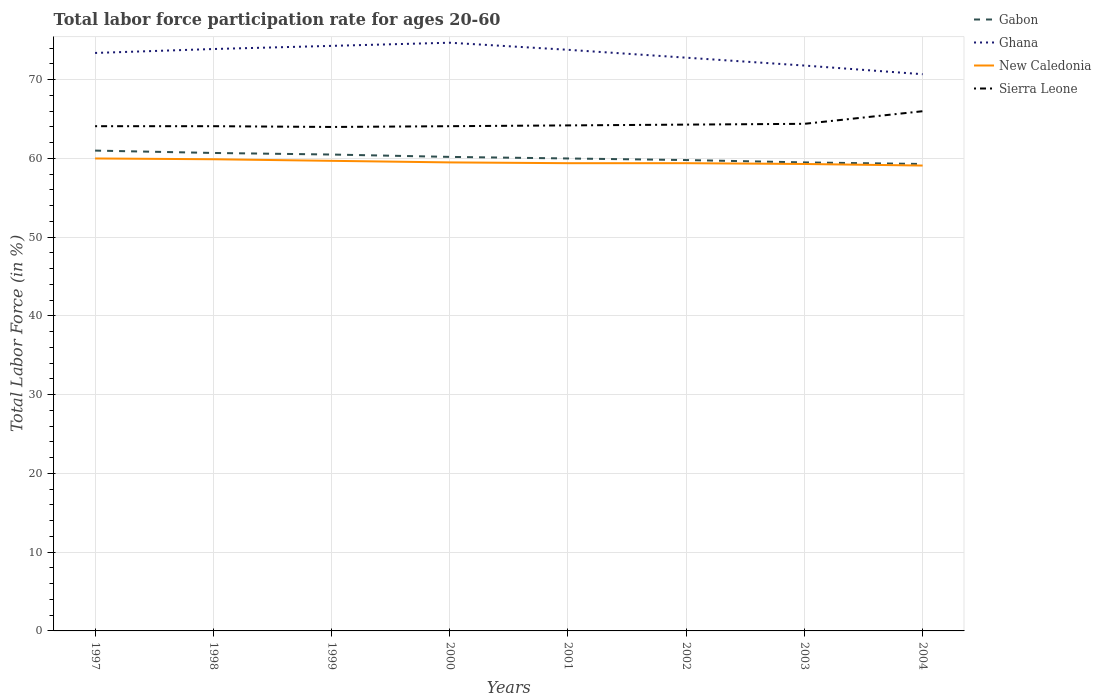Does the line corresponding to New Caledonia intersect with the line corresponding to Gabon?
Offer a terse response. No. Across all years, what is the maximum labor force participation rate in New Caledonia?
Make the answer very short. 59.1. What is the total labor force participation rate in Gabon in the graph?
Give a very brief answer. 0.2. What is the difference between the highest and the second highest labor force participation rate in Sierra Leone?
Make the answer very short. 2. What is the difference between the highest and the lowest labor force participation rate in Ghana?
Make the answer very short. 5. Are the values on the major ticks of Y-axis written in scientific E-notation?
Ensure brevity in your answer.  No. Does the graph contain grids?
Keep it short and to the point. Yes. Where does the legend appear in the graph?
Your response must be concise. Top right. How many legend labels are there?
Your response must be concise. 4. How are the legend labels stacked?
Give a very brief answer. Vertical. What is the title of the graph?
Give a very brief answer. Total labor force participation rate for ages 20-60. Does "Malta" appear as one of the legend labels in the graph?
Your answer should be compact. No. What is the label or title of the X-axis?
Give a very brief answer. Years. What is the Total Labor Force (in %) in Ghana in 1997?
Your answer should be very brief. 73.4. What is the Total Labor Force (in %) in New Caledonia in 1997?
Provide a succinct answer. 60. What is the Total Labor Force (in %) of Sierra Leone in 1997?
Your response must be concise. 64.1. What is the Total Labor Force (in %) of Gabon in 1998?
Provide a succinct answer. 60.7. What is the Total Labor Force (in %) of Ghana in 1998?
Make the answer very short. 73.9. What is the Total Labor Force (in %) of New Caledonia in 1998?
Offer a terse response. 59.9. What is the Total Labor Force (in %) of Sierra Leone in 1998?
Give a very brief answer. 64.1. What is the Total Labor Force (in %) in Gabon in 1999?
Your answer should be very brief. 60.5. What is the Total Labor Force (in %) of Ghana in 1999?
Ensure brevity in your answer.  74.3. What is the Total Labor Force (in %) of New Caledonia in 1999?
Offer a very short reply. 59.7. What is the Total Labor Force (in %) of Sierra Leone in 1999?
Provide a succinct answer. 64. What is the Total Labor Force (in %) of Gabon in 2000?
Keep it short and to the point. 60.2. What is the Total Labor Force (in %) in Ghana in 2000?
Provide a succinct answer. 74.7. What is the Total Labor Force (in %) of New Caledonia in 2000?
Make the answer very short. 59.5. What is the Total Labor Force (in %) of Sierra Leone in 2000?
Your answer should be compact. 64.1. What is the Total Labor Force (in %) in Ghana in 2001?
Ensure brevity in your answer.  73.8. What is the Total Labor Force (in %) in New Caledonia in 2001?
Offer a very short reply. 59.4. What is the Total Labor Force (in %) in Sierra Leone in 2001?
Keep it short and to the point. 64.2. What is the Total Labor Force (in %) in Gabon in 2002?
Keep it short and to the point. 59.8. What is the Total Labor Force (in %) in Ghana in 2002?
Your answer should be very brief. 72.8. What is the Total Labor Force (in %) in New Caledonia in 2002?
Your response must be concise. 59.4. What is the Total Labor Force (in %) in Sierra Leone in 2002?
Provide a succinct answer. 64.3. What is the Total Labor Force (in %) of Gabon in 2003?
Your response must be concise. 59.5. What is the Total Labor Force (in %) in Ghana in 2003?
Your answer should be very brief. 71.8. What is the Total Labor Force (in %) of New Caledonia in 2003?
Make the answer very short. 59.3. What is the Total Labor Force (in %) in Sierra Leone in 2003?
Ensure brevity in your answer.  64.4. What is the Total Labor Force (in %) of Gabon in 2004?
Keep it short and to the point. 59.3. What is the Total Labor Force (in %) of Ghana in 2004?
Offer a terse response. 70.7. What is the Total Labor Force (in %) of New Caledonia in 2004?
Ensure brevity in your answer.  59.1. What is the Total Labor Force (in %) in Sierra Leone in 2004?
Ensure brevity in your answer.  66. Across all years, what is the maximum Total Labor Force (in %) of Ghana?
Give a very brief answer. 74.7. Across all years, what is the maximum Total Labor Force (in %) in Sierra Leone?
Your response must be concise. 66. Across all years, what is the minimum Total Labor Force (in %) in Gabon?
Your answer should be very brief. 59.3. Across all years, what is the minimum Total Labor Force (in %) of Ghana?
Ensure brevity in your answer.  70.7. Across all years, what is the minimum Total Labor Force (in %) of New Caledonia?
Offer a terse response. 59.1. What is the total Total Labor Force (in %) of Gabon in the graph?
Keep it short and to the point. 481. What is the total Total Labor Force (in %) of Ghana in the graph?
Offer a terse response. 585.4. What is the total Total Labor Force (in %) of New Caledonia in the graph?
Your answer should be very brief. 476.3. What is the total Total Labor Force (in %) of Sierra Leone in the graph?
Ensure brevity in your answer.  515.2. What is the difference between the Total Labor Force (in %) of Ghana in 1997 and that in 1998?
Make the answer very short. -0.5. What is the difference between the Total Labor Force (in %) of Sierra Leone in 1997 and that in 1998?
Your answer should be compact. 0. What is the difference between the Total Labor Force (in %) of New Caledonia in 1997 and that in 1999?
Offer a terse response. 0.3. What is the difference between the Total Labor Force (in %) of Sierra Leone in 1997 and that in 2000?
Your answer should be compact. 0. What is the difference between the Total Labor Force (in %) of New Caledonia in 1997 and that in 2001?
Offer a very short reply. 0.6. What is the difference between the Total Labor Force (in %) in Sierra Leone in 1997 and that in 2002?
Offer a very short reply. -0.2. What is the difference between the Total Labor Force (in %) of Gabon in 1997 and that in 2003?
Your answer should be compact. 1.5. What is the difference between the Total Labor Force (in %) of Ghana in 1997 and that in 2003?
Offer a terse response. 1.6. What is the difference between the Total Labor Force (in %) of Sierra Leone in 1997 and that in 2003?
Provide a short and direct response. -0.3. What is the difference between the Total Labor Force (in %) in Ghana in 1997 and that in 2004?
Make the answer very short. 2.7. What is the difference between the Total Labor Force (in %) in New Caledonia in 1997 and that in 2004?
Ensure brevity in your answer.  0.9. What is the difference between the Total Labor Force (in %) of Sierra Leone in 1997 and that in 2004?
Provide a short and direct response. -1.9. What is the difference between the Total Labor Force (in %) in Sierra Leone in 1998 and that in 1999?
Your answer should be compact. 0.1. What is the difference between the Total Labor Force (in %) in Gabon in 1998 and that in 2000?
Provide a succinct answer. 0.5. What is the difference between the Total Labor Force (in %) of Ghana in 1998 and that in 2000?
Make the answer very short. -0.8. What is the difference between the Total Labor Force (in %) in New Caledonia in 1998 and that in 2000?
Keep it short and to the point. 0.4. What is the difference between the Total Labor Force (in %) in Gabon in 1998 and that in 2002?
Provide a short and direct response. 0.9. What is the difference between the Total Labor Force (in %) in Ghana in 1998 and that in 2002?
Your answer should be compact. 1.1. What is the difference between the Total Labor Force (in %) in New Caledonia in 1998 and that in 2002?
Your answer should be compact. 0.5. What is the difference between the Total Labor Force (in %) in Sierra Leone in 1998 and that in 2002?
Keep it short and to the point. -0.2. What is the difference between the Total Labor Force (in %) of Gabon in 1998 and that in 2003?
Provide a short and direct response. 1.2. What is the difference between the Total Labor Force (in %) in New Caledonia in 1998 and that in 2003?
Offer a terse response. 0.6. What is the difference between the Total Labor Force (in %) of Sierra Leone in 1998 and that in 2003?
Your answer should be compact. -0.3. What is the difference between the Total Labor Force (in %) of Ghana in 1998 and that in 2004?
Your answer should be very brief. 3.2. What is the difference between the Total Labor Force (in %) of Sierra Leone in 1998 and that in 2004?
Provide a succinct answer. -1.9. What is the difference between the Total Labor Force (in %) of New Caledonia in 1999 and that in 2000?
Provide a short and direct response. 0.2. What is the difference between the Total Labor Force (in %) in Gabon in 1999 and that in 2001?
Provide a short and direct response. 0.5. What is the difference between the Total Labor Force (in %) in Ghana in 1999 and that in 2001?
Ensure brevity in your answer.  0.5. What is the difference between the Total Labor Force (in %) in New Caledonia in 1999 and that in 2001?
Offer a very short reply. 0.3. What is the difference between the Total Labor Force (in %) of Sierra Leone in 1999 and that in 2001?
Keep it short and to the point. -0.2. What is the difference between the Total Labor Force (in %) of Gabon in 1999 and that in 2002?
Give a very brief answer. 0.7. What is the difference between the Total Labor Force (in %) in Ghana in 1999 and that in 2002?
Keep it short and to the point. 1.5. What is the difference between the Total Labor Force (in %) of Ghana in 1999 and that in 2003?
Offer a very short reply. 2.5. What is the difference between the Total Labor Force (in %) of New Caledonia in 1999 and that in 2003?
Your answer should be very brief. 0.4. What is the difference between the Total Labor Force (in %) in Sierra Leone in 1999 and that in 2004?
Provide a short and direct response. -2. What is the difference between the Total Labor Force (in %) in New Caledonia in 2000 and that in 2001?
Your answer should be compact. 0.1. What is the difference between the Total Labor Force (in %) in Sierra Leone in 2000 and that in 2001?
Give a very brief answer. -0.1. What is the difference between the Total Labor Force (in %) in New Caledonia in 2000 and that in 2002?
Provide a short and direct response. 0.1. What is the difference between the Total Labor Force (in %) of Sierra Leone in 2000 and that in 2002?
Offer a terse response. -0.2. What is the difference between the Total Labor Force (in %) in New Caledonia in 2000 and that in 2004?
Make the answer very short. 0.4. What is the difference between the Total Labor Force (in %) of Sierra Leone in 2000 and that in 2004?
Offer a terse response. -1.9. What is the difference between the Total Labor Force (in %) of Gabon in 2001 and that in 2002?
Offer a terse response. 0.2. What is the difference between the Total Labor Force (in %) of Ghana in 2001 and that in 2003?
Give a very brief answer. 2. What is the difference between the Total Labor Force (in %) of New Caledonia in 2001 and that in 2003?
Provide a short and direct response. 0.1. What is the difference between the Total Labor Force (in %) in Ghana in 2001 and that in 2004?
Give a very brief answer. 3.1. What is the difference between the Total Labor Force (in %) of New Caledonia in 2001 and that in 2004?
Keep it short and to the point. 0.3. What is the difference between the Total Labor Force (in %) of Ghana in 2002 and that in 2003?
Your answer should be compact. 1. What is the difference between the Total Labor Force (in %) of New Caledonia in 2002 and that in 2003?
Ensure brevity in your answer.  0.1. What is the difference between the Total Labor Force (in %) in Gabon in 2002 and that in 2004?
Your answer should be very brief. 0.5. What is the difference between the Total Labor Force (in %) in Ghana in 2002 and that in 2004?
Give a very brief answer. 2.1. What is the difference between the Total Labor Force (in %) in Gabon in 2003 and that in 2004?
Keep it short and to the point. 0.2. What is the difference between the Total Labor Force (in %) of Sierra Leone in 2003 and that in 2004?
Your response must be concise. -1.6. What is the difference between the Total Labor Force (in %) of Gabon in 1997 and the Total Labor Force (in %) of New Caledonia in 1998?
Give a very brief answer. 1.1. What is the difference between the Total Labor Force (in %) in Gabon in 1997 and the Total Labor Force (in %) in Sierra Leone in 1998?
Your response must be concise. -3.1. What is the difference between the Total Labor Force (in %) of Ghana in 1997 and the Total Labor Force (in %) of New Caledonia in 1999?
Give a very brief answer. 13.7. What is the difference between the Total Labor Force (in %) of New Caledonia in 1997 and the Total Labor Force (in %) of Sierra Leone in 1999?
Give a very brief answer. -4. What is the difference between the Total Labor Force (in %) in Gabon in 1997 and the Total Labor Force (in %) in Ghana in 2000?
Your response must be concise. -13.7. What is the difference between the Total Labor Force (in %) of Gabon in 1997 and the Total Labor Force (in %) of New Caledonia in 2000?
Keep it short and to the point. 1.5. What is the difference between the Total Labor Force (in %) of Gabon in 1997 and the Total Labor Force (in %) of Ghana in 2001?
Make the answer very short. -12.8. What is the difference between the Total Labor Force (in %) of Gabon in 1997 and the Total Labor Force (in %) of Ghana in 2002?
Ensure brevity in your answer.  -11.8. What is the difference between the Total Labor Force (in %) in Gabon in 1997 and the Total Labor Force (in %) in Sierra Leone in 2002?
Give a very brief answer. -3.3. What is the difference between the Total Labor Force (in %) of Ghana in 1997 and the Total Labor Force (in %) of New Caledonia in 2002?
Offer a very short reply. 14. What is the difference between the Total Labor Force (in %) of New Caledonia in 1997 and the Total Labor Force (in %) of Sierra Leone in 2002?
Offer a terse response. -4.3. What is the difference between the Total Labor Force (in %) in Gabon in 1997 and the Total Labor Force (in %) in New Caledonia in 2003?
Your answer should be compact. 1.7. What is the difference between the Total Labor Force (in %) in Gabon in 1997 and the Total Labor Force (in %) in Sierra Leone in 2003?
Offer a very short reply. -3.4. What is the difference between the Total Labor Force (in %) in Ghana in 1997 and the Total Labor Force (in %) in New Caledonia in 2003?
Offer a terse response. 14.1. What is the difference between the Total Labor Force (in %) of Ghana in 1997 and the Total Labor Force (in %) of Sierra Leone in 2003?
Give a very brief answer. 9. What is the difference between the Total Labor Force (in %) of Gabon in 1997 and the Total Labor Force (in %) of New Caledonia in 2004?
Offer a very short reply. 1.9. What is the difference between the Total Labor Force (in %) in Gabon in 1997 and the Total Labor Force (in %) in Sierra Leone in 2004?
Ensure brevity in your answer.  -5. What is the difference between the Total Labor Force (in %) in Ghana in 1997 and the Total Labor Force (in %) in New Caledonia in 2004?
Your answer should be compact. 14.3. What is the difference between the Total Labor Force (in %) in New Caledonia in 1997 and the Total Labor Force (in %) in Sierra Leone in 2004?
Ensure brevity in your answer.  -6. What is the difference between the Total Labor Force (in %) of Gabon in 1998 and the Total Labor Force (in %) of Ghana in 1999?
Keep it short and to the point. -13.6. What is the difference between the Total Labor Force (in %) of Gabon in 1998 and the Total Labor Force (in %) of Ghana in 2000?
Your answer should be very brief. -14. What is the difference between the Total Labor Force (in %) in Ghana in 1998 and the Total Labor Force (in %) in Sierra Leone in 2000?
Make the answer very short. 9.8. What is the difference between the Total Labor Force (in %) of New Caledonia in 1998 and the Total Labor Force (in %) of Sierra Leone in 2000?
Offer a very short reply. -4.2. What is the difference between the Total Labor Force (in %) of Gabon in 1998 and the Total Labor Force (in %) of Sierra Leone in 2001?
Make the answer very short. -3.5. What is the difference between the Total Labor Force (in %) in Ghana in 1998 and the Total Labor Force (in %) in Sierra Leone in 2001?
Ensure brevity in your answer.  9.7. What is the difference between the Total Labor Force (in %) of Gabon in 1998 and the Total Labor Force (in %) of Ghana in 2002?
Give a very brief answer. -12.1. What is the difference between the Total Labor Force (in %) in Gabon in 1998 and the Total Labor Force (in %) in Sierra Leone in 2002?
Provide a succinct answer. -3.6. What is the difference between the Total Labor Force (in %) in Ghana in 1998 and the Total Labor Force (in %) in New Caledonia in 2002?
Provide a short and direct response. 14.5. What is the difference between the Total Labor Force (in %) of Ghana in 1998 and the Total Labor Force (in %) of Sierra Leone in 2002?
Provide a succinct answer. 9.6. What is the difference between the Total Labor Force (in %) of New Caledonia in 1998 and the Total Labor Force (in %) of Sierra Leone in 2002?
Give a very brief answer. -4.4. What is the difference between the Total Labor Force (in %) in Gabon in 1998 and the Total Labor Force (in %) in New Caledonia in 2003?
Make the answer very short. 1.4. What is the difference between the Total Labor Force (in %) of Gabon in 1998 and the Total Labor Force (in %) of Sierra Leone in 2003?
Your answer should be compact. -3.7. What is the difference between the Total Labor Force (in %) in Ghana in 1998 and the Total Labor Force (in %) in New Caledonia in 2003?
Your answer should be very brief. 14.6. What is the difference between the Total Labor Force (in %) of Ghana in 1998 and the Total Labor Force (in %) of Sierra Leone in 2003?
Offer a very short reply. 9.5. What is the difference between the Total Labor Force (in %) in Gabon in 1998 and the Total Labor Force (in %) in Ghana in 2004?
Provide a succinct answer. -10. What is the difference between the Total Labor Force (in %) of Gabon in 1998 and the Total Labor Force (in %) of New Caledonia in 2004?
Give a very brief answer. 1.6. What is the difference between the Total Labor Force (in %) of Ghana in 1998 and the Total Labor Force (in %) of New Caledonia in 2004?
Provide a succinct answer. 14.8. What is the difference between the Total Labor Force (in %) in Ghana in 1998 and the Total Labor Force (in %) in Sierra Leone in 2004?
Provide a succinct answer. 7.9. What is the difference between the Total Labor Force (in %) of New Caledonia in 1998 and the Total Labor Force (in %) of Sierra Leone in 2004?
Your response must be concise. -6.1. What is the difference between the Total Labor Force (in %) of Gabon in 1999 and the Total Labor Force (in %) of Ghana in 2000?
Ensure brevity in your answer.  -14.2. What is the difference between the Total Labor Force (in %) of Gabon in 1999 and the Total Labor Force (in %) of New Caledonia in 2000?
Ensure brevity in your answer.  1. What is the difference between the Total Labor Force (in %) in Gabon in 1999 and the Total Labor Force (in %) in New Caledonia in 2001?
Offer a terse response. 1.1. What is the difference between the Total Labor Force (in %) of Gabon in 1999 and the Total Labor Force (in %) of Sierra Leone in 2001?
Make the answer very short. -3.7. What is the difference between the Total Labor Force (in %) of Ghana in 1999 and the Total Labor Force (in %) of New Caledonia in 2001?
Your answer should be compact. 14.9. What is the difference between the Total Labor Force (in %) of Ghana in 1999 and the Total Labor Force (in %) of Sierra Leone in 2001?
Offer a terse response. 10.1. What is the difference between the Total Labor Force (in %) of Gabon in 1999 and the Total Labor Force (in %) of New Caledonia in 2002?
Provide a short and direct response. 1.1. What is the difference between the Total Labor Force (in %) in Gabon in 1999 and the Total Labor Force (in %) in Sierra Leone in 2003?
Your answer should be very brief. -3.9. What is the difference between the Total Labor Force (in %) in Ghana in 1999 and the Total Labor Force (in %) in Sierra Leone in 2003?
Keep it short and to the point. 9.9. What is the difference between the Total Labor Force (in %) of Gabon in 1999 and the Total Labor Force (in %) of New Caledonia in 2004?
Offer a terse response. 1.4. What is the difference between the Total Labor Force (in %) of Gabon in 2000 and the Total Labor Force (in %) of Ghana in 2001?
Keep it short and to the point. -13.6. What is the difference between the Total Labor Force (in %) of Gabon in 2000 and the Total Labor Force (in %) of New Caledonia in 2001?
Your answer should be very brief. 0.8. What is the difference between the Total Labor Force (in %) of New Caledonia in 2000 and the Total Labor Force (in %) of Sierra Leone in 2001?
Your answer should be very brief. -4.7. What is the difference between the Total Labor Force (in %) in Ghana in 2000 and the Total Labor Force (in %) in Sierra Leone in 2002?
Your answer should be very brief. 10.4. What is the difference between the Total Labor Force (in %) in New Caledonia in 2000 and the Total Labor Force (in %) in Sierra Leone in 2002?
Your answer should be compact. -4.8. What is the difference between the Total Labor Force (in %) of Gabon in 2000 and the Total Labor Force (in %) of Ghana in 2003?
Your answer should be compact. -11.6. What is the difference between the Total Labor Force (in %) in Gabon in 2000 and the Total Labor Force (in %) in Sierra Leone in 2003?
Make the answer very short. -4.2. What is the difference between the Total Labor Force (in %) of Ghana in 2000 and the Total Labor Force (in %) of Sierra Leone in 2003?
Your answer should be very brief. 10.3. What is the difference between the Total Labor Force (in %) of New Caledonia in 2000 and the Total Labor Force (in %) of Sierra Leone in 2003?
Make the answer very short. -4.9. What is the difference between the Total Labor Force (in %) of Gabon in 2000 and the Total Labor Force (in %) of Sierra Leone in 2004?
Make the answer very short. -5.8. What is the difference between the Total Labor Force (in %) in New Caledonia in 2000 and the Total Labor Force (in %) in Sierra Leone in 2004?
Offer a terse response. -6.5. What is the difference between the Total Labor Force (in %) of Gabon in 2001 and the Total Labor Force (in %) of Sierra Leone in 2002?
Offer a very short reply. -4.3. What is the difference between the Total Labor Force (in %) of New Caledonia in 2001 and the Total Labor Force (in %) of Sierra Leone in 2002?
Keep it short and to the point. -4.9. What is the difference between the Total Labor Force (in %) in Ghana in 2001 and the Total Labor Force (in %) in New Caledonia in 2003?
Offer a terse response. 14.5. What is the difference between the Total Labor Force (in %) in Ghana in 2001 and the Total Labor Force (in %) in Sierra Leone in 2003?
Give a very brief answer. 9.4. What is the difference between the Total Labor Force (in %) of New Caledonia in 2001 and the Total Labor Force (in %) of Sierra Leone in 2003?
Keep it short and to the point. -5. What is the difference between the Total Labor Force (in %) in Ghana in 2001 and the Total Labor Force (in %) in New Caledonia in 2004?
Provide a succinct answer. 14.7. What is the difference between the Total Labor Force (in %) in Gabon in 2002 and the Total Labor Force (in %) in New Caledonia in 2003?
Offer a terse response. 0.5. What is the difference between the Total Labor Force (in %) of Ghana in 2002 and the Total Labor Force (in %) of New Caledonia in 2003?
Your answer should be compact. 13.5. What is the difference between the Total Labor Force (in %) in Ghana in 2002 and the Total Labor Force (in %) in Sierra Leone in 2003?
Your answer should be compact. 8.4. What is the difference between the Total Labor Force (in %) of New Caledonia in 2002 and the Total Labor Force (in %) of Sierra Leone in 2003?
Your response must be concise. -5. What is the difference between the Total Labor Force (in %) in Ghana in 2002 and the Total Labor Force (in %) in Sierra Leone in 2004?
Offer a very short reply. 6.8. What is the difference between the Total Labor Force (in %) in New Caledonia in 2002 and the Total Labor Force (in %) in Sierra Leone in 2004?
Your answer should be compact. -6.6. What is the difference between the Total Labor Force (in %) of Gabon in 2003 and the Total Labor Force (in %) of Ghana in 2004?
Make the answer very short. -11.2. What is the average Total Labor Force (in %) in Gabon per year?
Give a very brief answer. 60.12. What is the average Total Labor Force (in %) in Ghana per year?
Keep it short and to the point. 73.17. What is the average Total Labor Force (in %) of New Caledonia per year?
Your answer should be very brief. 59.54. What is the average Total Labor Force (in %) of Sierra Leone per year?
Your answer should be compact. 64.4. In the year 1997, what is the difference between the Total Labor Force (in %) of Gabon and Total Labor Force (in %) of Sierra Leone?
Make the answer very short. -3.1. In the year 1997, what is the difference between the Total Labor Force (in %) of Ghana and Total Labor Force (in %) of New Caledonia?
Your answer should be very brief. 13.4. In the year 1997, what is the difference between the Total Labor Force (in %) in Ghana and Total Labor Force (in %) in Sierra Leone?
Offer a very short reply. 9.3. In the year 1998, what is the difference between the Total Labor Force (in %) in Gabon and Total Labor Force (in %) in Ghana?
Your answer should be compact. -13.2. In the year 1998, what is the difference between the Total Labor Force (in %) of Gabon and Total Labor Force (in %) of Sierra Leone?
Provide a short and direct response. -3.4. In the year 1998, what is the difference between the Total Labor Force (in %) in Ghana and Total Labor Force (in %) in New Caledonia?
Provide a short and direct response. 14. In the year 1999, what is the difference between the Total Labor Force (in %) in Gabon and Total Labor Force (in %) in New Caledonia?
Your response must be concise. 0.8. In the year 1999, what is the difference between the Total Labor Force (in %) in Gabon and Total Labor Force (in %) in Sierra Leone?
Offer a terse response. -3.5. In the year 1999, what is the difference between the Total Labor Force (in %) in Ghana and Total Labor Force (in %) in Sierra Leone?
Give a very brief answer. 10.3. In the year 2000, what is the difference between the Total Labor Force (in %) in Gabon and Total Labor Force (in %) in Ghana?
Your answer should be very brief. -14.5. In the year 2000, what is the difference between the Total Labor Force (in %) of Ghana and Total Labor Force (in %) of New Caledonia?
Offer a terse response. 15.2. In the year 2000, what is the difference between the Total Labor Force (in %) in New Caledonia and Total Labor Force (in %) in Sierra Leone?
Ensure brevity in your answer.  -4.6. In the year 2001, what is the difference between the Total Labor Force (in %) in Gabon and Total Labor Force (in %) in New Caledonia?
Make the answer very short. 0.6. In the year 2001, what is the difference between the Total Labor Force (in %) in Gabon and Total Labor Force (in %) in Sierra Leone?
Provide a short and direct response. -4.2. In the year 2001, what is the difference between the Total Labor Force (in %) in New Caledonia and Total Labor Force (in %) in Sierra Leone?
Provide a short and direct response. -4.8. In the year 2002, what is the difference between the Total Labor Force (in %) in Gabon and Total Labor Force (in %) in Ghana?
Your response must be concise. -13. In the year 2002, what is the difference between the Total Labor Force (in %) in Ghana and Total Labor Force (in %) in Sierra Leone?
Your response must be concise. 8.5. In the year 2003, what is the difference between the Total Labor Force (in %) in Ghana and Total Labor Force (in %) in New Caledonia?
Keep it short and to the point. 12.5. In the year 2003, what is the difference between the Total Labor Force (in %) of Ghana and Total Labor Force (in %) of Sierra Leone?
Keep it short and to the point. 7.4. In the year 2003, what is the difference between the Total Labor Force (in %) of New Caledonia and Total Labor Force (in %) of Sierra Leone?
Give a very brief answer. -5.1. In the year 2004, what is the difference between the Total Labor Force (in %) of Gabon and Total Labor Force (in %) of Ghana?
Offer a terse response. -11.4. In the year 2004, what is the difference between the Total Labor Force (in %) in New Caledonia and Total Labor Force (in %) in Sierra Leone?
Make the answer very short. -6.9. What is the ratio of the Total Labor Force (in %) in Gabon in 1997 to that in 1998?
Your response must be concise. 1. What is the ratio of the Total Labor Force (in %) of Gabon in 1997 to that in 1999?
Make the answer very short. 1.01. What is the ratio of the Total Labor Force (in %) of Ghana in 1997 to that in 1999?
Offer a very short reply. 0.99. What is the ratio of the Total Labor Force (in %) in New Caledonia in 1997 to that in 1999?
Your answer should be compact. 1. What is the ratio of the Total Labor Force (in %) in Sierra Leone in 1997 to that in 1999?
Your response must be concise. 1. What is the ratio of the Total Labor Force (in %) in Gabon in 1997 to that in 2000?
Offer a terse response. 1.01. What is the ratio of the Total Labor Force (in %) of Ghana in 1997 to that in 2000?
Offer a very short reply. 0.98. What is the ratio of the Total Labor Force (in %) in New Caledonia in 1997 to that in 2000?
Provide a succinct answer. 1.01. What is the ratio of the Total Labor Force (in %) of Gabon in 1997 to that in 2001?
Ensure brevity in your answer.  1.02. What is the ratio of the Total Labor Force (in %) of New Caledonia in 1997 to that in 2001?
Your answer should be compact. 1.01. What is the ratio of the Total Labor Force (in %) of Gabon in 1997 to that in 2002?
Offer a terse response. 1.02. What is the ratio of the Total Labor Force (in %) in Ghana in 1997 to that in 2002?
Offer a very short reply. 1.01. What is the ratio of the Total Labor Force (in %) in New Caledonia in 1997 to that in 2002?
Provide a succinct answer. 1.01. What is the ratio of the Total Labor Force (in %) in Sierra Leone in 1997 to that in 2002?
Your answer should be very brief. 1. What is the ratio of the Total Labor Force (in %) of Gabon in 1997 to that in 2003?
Offer a very short reply. 1.03. What is the ratio of the Total Labor Force (in %) in Ghana in 1997 to that in 2003?
Offer a very short reply. 1.02. What is the ratio of the Total Labor Force (in %) in New Caledonia in 1997 to that in 2003?
Provide a succinct answer. 1.01. What is the ratio of the Total Labor Force (in %) of Sierra Leone in 1997 to that in 2003?
Provide a short and direct response. 1. What is the ratio of the Total Labor Force (in %) in Gabon in 1997 to that in 2004?
Ensure brevity in your answer.  1.03. What is the ratio of the Total Labor Force (in %) in Ghana in 1997 to that in 2004?
Offer a terse response. 1.04. What is the ratio of the Total Labor Force (in %) in New Caledonia in 1997 to that in 2004?
Your answer should be compact. 1.02. What is the ratio of the Total Labor Force (in %) of Sierra Leone in 1997 to that in 2004?
Keep it short and to the point. 0.97. What is the ratio of the Total Labor Force (in %) of Gabon in 1998 to that in 1999?
Keep it short and to the point. 1. What is the ratio of the Total Labor Force (in %) in Ghana in 1998 to that in 1999?
Your answer should be compact. 0.99. What is the ratio of the Total Labor Force (in %) of New Caledonia in 1998 to that in 1999?
Offer a terse response. 1. What is the ratio of the Total Labor Force (in %) of Sierra Leone in 1998 to that in 1999?
Provide a succinct answer. 1. What is the ratio of the Total Labor Force (in %) of Gabon in 1998 to that in 2000?
Keep it short and to the point. 1.01. What is the ratio of the Total Labor Force (in %) of Ghana in 1998 to that in 2000?
Offer a very short reply. 0.99. What is the ratio of the Total Labor Force (in %) of Sierra Leone in 1998 to that in 2000?
Offer a very short reply. 1. What is the ratio of the Total Labor Force (in %) in Gabon in 1998 to that in 2001?
Provide a succinct answer. 1.01. What is the ratio of the Total Labor Force (in %) in New Caledonia in 1998 to that in 2001?
Your answer should be very brief. 1.01. What is the ratio of the Total Labor Force (in %) in Gabon in 1998 to that in 2002?
Keep it short and to the point. 1.02. What is the ratio of the Total Labor Force (in %) of Ghana in 1998 to that in 2002?
Your answer should be very brief. 1.02. What is the ratio of the Total Labor Force (in %) in New Caledonia in 1998 to that in 2002?
Ensure brevity in your answer.  1.01. What is the ratio of the Total Labor Force (in %) of Gabon in 1998 to that in 2003?
Your response must be concise. 1.02. What is the ratio of the Total Labor Force (in %) in Ghana in 1998 to that in 2003?
Offer a very short reply. 1.03. What is the ratio of the Total Labor Force (in %) of New Caledonia in 1998 to that in 2003?
Provide a short and direct response. 1.01. What is the ratio of the Total Labor Force (in %) in Gabon in 1998 to that in 2004?
Give a very brief answer. 1.02. What is the ratio of the Total Labor Force (in %) of Ghana in 1998 to that in 2004?
Make the answer very short. 1.05. What is the ratio of the Total Labor Force (in %) of New Caledonia in 1998 to that in 2004?
Your response must be concise. 1.01. What is the ratio of the Total Labor Force (in %) in Sierra Leone in 1998 to that in 2004?
Offer a very short reply. 0.97. What is the ratio of the Total Labor Force (in %) in Ghana in 1999 to that in 2000?
Your answer should be compact. 0.99. What is the ratio of the Total Labor Force (in %) of Gabon in 1999 to that in 2001?
Ensure brevity in your answer.  1.01. What is the ratio of the Total Labor Force (in %) in Ghana in 1999 to that in 2001?
Your answer should be very brief. 1.01. What is the ratio of the Total Labor Force (in %) in Sierra Leone in 1999 to that in 2001?
Your answer should be very brief. 1. What is the ratio of the Total Labor Force (in %) in Gabon in 1999 to that in 2002?
Provide a succinct answer. 1.01. What is the ratio of the Total Labor Force (in %) of Ghana in 1999 to that in 2002?
Make the answer very short. 1.02. What is the ratio of the Total Labor Force (in %) of New Caledonia in 1999 to that in 2002?
Offer a very short reply. 1.01. What is the ratio of the Total Labor Force (in %) in Gabon in 1999 to that in 2003?
Your answer should be compact. 1.02. What is the ratio of the Total Labor Force (in %) of Ghana in 1999 to that in 2003?
Offer a terse response. 1.03. What is the ratio of the Total Labor Force (in %) in Sierra Leone in 1999 to that in 2003?
Ensure brevity in your answer.  0.99. What is the ratio of the Total Labor Force (in %) in Gabon in 1999 to that in 2004?
Keep it short and to the point. 1.02. What is the ratio of the Total Labor Force (in %) of Ghana in 1999 to that in 2004?
Provide a succinct answer. 1.05. What is the ratio of the Total Labor Force (in %) of New Caledonia in 1999 to that in 2004?
Provide a short and direct response. 1.01. What is the ratio of the Total Labor Force (in %) of Sierra Leone in 1999 to that in 2004?
Give a very brief answer. 0.97. What is the ratio of the Total Labor Force (in %) of Gabon in 2000 to that in 2001?
Keep it short and to the point. 1. What is the ratio of the Total Labor Force (in %) of Ghana in 2000 to that in 2001?
Your response must be concise. 1.01. What is the ratio of the Total Labor Force (in %) of Sierra Leone in 2000 to that in 2001?
Your answer should be compact. 1. What is the ratio of the Total Labor Force (in %) of Gabon in 2000 to that in 2002?
Provide a short and direct response. 1.01. What is the ratio of the Total Labor Force (in %) of Ghana in 2000 to that in 2002?
Make the answer very short. 1.03. What is the ratio of the Total Labor Force (in %) of New Caledonia in 2000 to that in 2002?
Make the answer very short. 1. What is the ratio of the Total Labor Force (in %) of Gabon in 2000 to that in 2003?
Your answer should be very brief. 1.01. What is the ratio of the Total Labor Force (in %) of Ghana in 2000 to that in 2003?
Give a very brief answer. 1.04. What is the ratio of the Total Labor Force (in %) of New Caledonia in 2000 to that in 2003?
Make the answer very short. 1. What is the ratio of the Total Labor Force (in %) of Gabon in 2000 to that in 2004?
Your answer should be compact. 1.02. What is the ratio of the Total Labor Force (in %) in Ghana in 2000 to that in 2004?
Your answer should be compact. 1.06. What is the ratio of the Total Labor Force (in %) of New Caledonia in 2000 to that in 2004?
Provide a succinct answer. 1.01. What is the ratio of the Total Labor Force (in %) of Sierra Leone in 2000 to that in 2004?
Your answer should be very brief. 0.97. What is the ratio of the Total Labor Force (in %) of Ghana in 2001 to that in 2002?
Keep it short and to the point. 1.01. What is the ratio of the Total Labor Force (in %) in Sierra Leone in 2001 to that in 2002?
Offer a very short reply. 1. What is the ratio of the Total Labor Force (in %) in Gabon in 2001 to that in 2003?
Ensure brevity in your answer.  1.01. What is the ratio of the Total Labor Force (in %) of Ghana in 2001 to that in 2003?
Provide a short and direct response. 1.03. What is the ratio of the Total Labor Force (in %) in Gabon in 2001 to that in 2004?
Give a very brief answer. 1.01. What is the ratio of the Total Labor Force (in %) in Ghana in 2001 to that in 2004?
Ensure brevity in your answer.  1.04. What is the ratio of the Total Labor Force (in %) in Sierra Leone in 2001 to that in 2004?
Give a very brief answer. 0.97. What is the ratio of the Total Labor Force (in %) of Gabon in 2002 to that in 2003?
Your response must be concise. 1. What is the ratio of the Total Labor Force (in %) of Ghana in 2002 to that in 2003?
Give a very brief answer. 1.01. What is the ratio of the Total Labor Force (in %) in Sierra Leone in 2002 to that in 2003?
Ensure brevity in your answer.  1. What is the ratio of the Total Labor Force (in %) in Gabon in 2002 to that in 2004?
Provide a short and direct response. 1.01. What is the ratio of the Total Labor Force (in %) in Ghana in 2002 to that in 2004?
Offer a very short reply. 1.03. What is the ratio of the Total Labor Force (in %) in New Caledonia in 2002 to that in 2004?
Your answer should be compact. 1.01. What is the ratio of the Total Labor Force (in %) in Sierra Leone in 2002 to that in 2004?
Provide a short and direct response. 0.97. What is the ratio of the Total Labor Force (in %) of Gabon in 2003 to that in 2004?
Your response must be concise. 1. What is the ratio of the Total Labor Force (in %) of Ghana in 2003 to that in 2004?
Provide a short and direct response. 1.02. What is the ratio of the Total Labor Force (in %) in Sierra Leone in 2003 to that in 2004?
Provide a short and direct response. 0.98. What is the difference between the highest and the second highest Total Labor Force (in %) of Gabon?
Provide a short and direct response. 0.3. What is the difference between the highest and the second highest Total Labor Force (in %) of Ghana?
Your answer should be very brief. 0.4. What is the difference between the highest and the second highest Total Labor Force (in %) in New Caledonia?
Make the answer very short. 0.1. What is the difference between the highest and the lowest Total Labor Force (in %) of Gabon?
Provide a succinct answer. 1.7. 